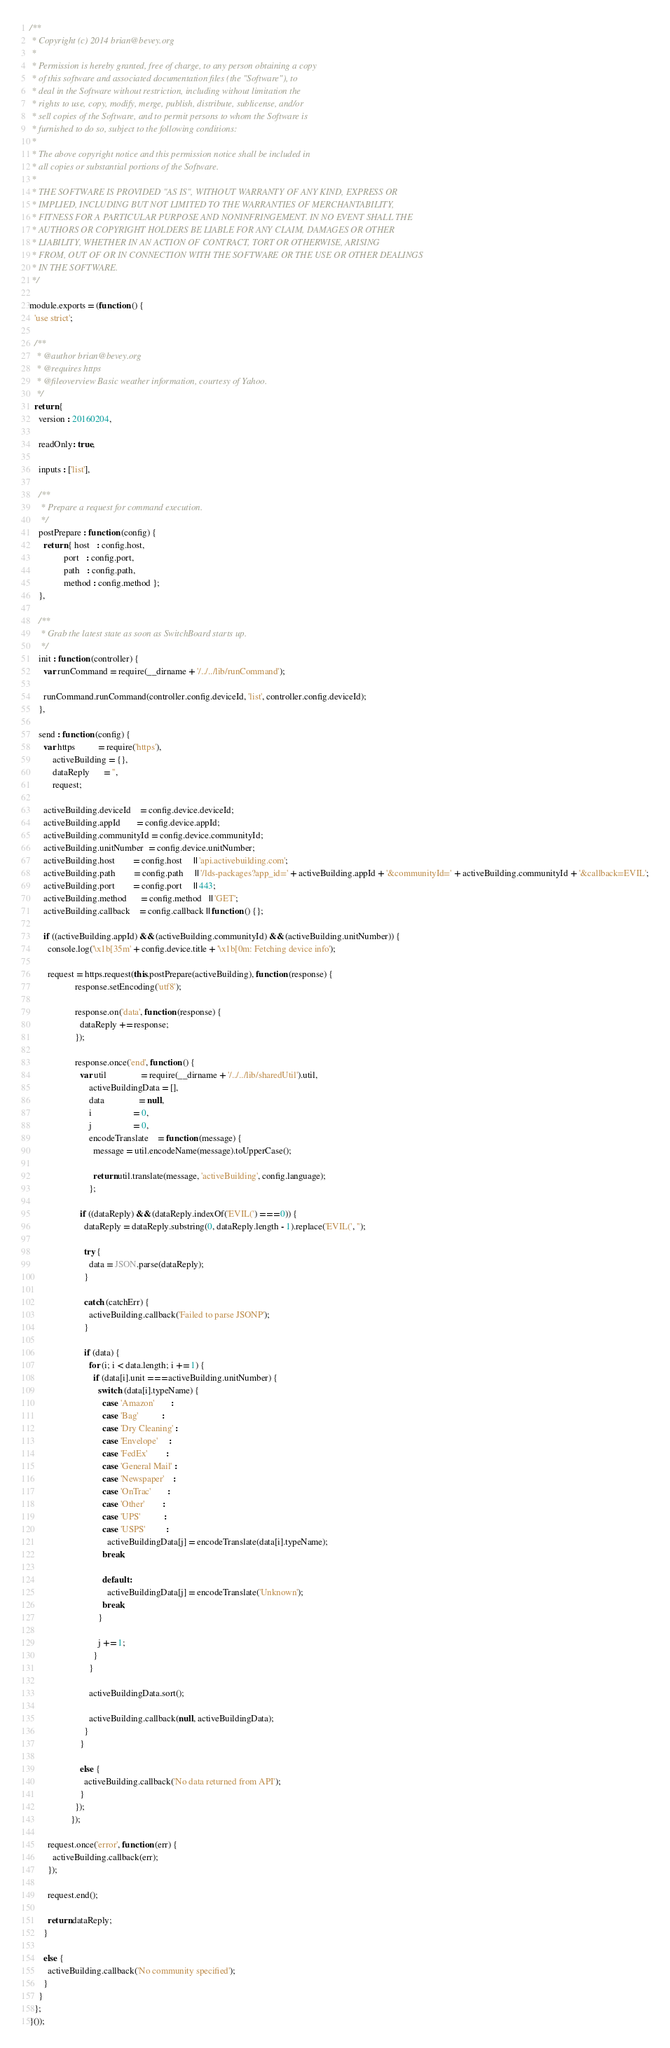Convert code to text. <code><loc_0><loc_0><loc_500><loc_500><_JavaScript_>/**
 * Copyright (c) 2014 brian@bevey.org
 *
 * Permission is hereby granted, free of charge, to any person obtaining a copy
 * of this software and associated documentation files (the "Software"), to
 * deal in the Software without restriction, including without limitation the
 * rights to use, copy, modify, merge, publish, distribute, sublicense, and/or
 * sell copies of the Software, and to permit persons to whom the Software is
 * furnished to do so, subject to the following conditions:
 *
 * The above copyright notice and this permission notice shall be included in
 * all copies or substantial portions of the Software.
 *
 * THE SOFTWARE IS PROVIDED "AS IS", WITHOUT WARRANTY OF ANY KIND, EXPRESS OR
 * IMPLIED, INCLUDING BUT NOT LIMITED TO THE WARRANTIES OF MERCHANTABILITY,
 * FITNESS FOR A PARTICULAR PURPOSE AND NONINFRINGEMENT. IN NO EVENT SHALL THE
 * AUTHORS OR COPYRIGHT HOLDERS BE LIABLE FOR ANY CLAIM, DAMAGES OR OTHER
 * LIABILITY, WHETHER IN AN ACTION OF CONTRACT, TORT OR OTHERWISE, ARISING
 * FROM, OUT OF OR IN CONNECTION WITH THE SOFTWARE OR THE USE OR OTHER DEALINGS
 * IN THE SOFTWARE.
 */

module.exports = (function () {
  'use strict';

  /**
   * @author brian@bevey.org
   * @requires https
   * @fileoverview Basic weather information, courtesy of Yahoo.
   */
  return {
    version : 20160204,

    readOnly: true,

    inputs : ['list'],

    /**
     * Prepare a request for command execution.
     */
    postPrepare : function (config) {
      return { host   : config.host,
               port   : config.port,
               path   : config.path,
               method : config.method };
    },

    /**
     * Grab the latest state as soon as SwitchBoard starts up.
     */
    init : function (controller) {
      var runCommand = require(__dirname + '/../../lib/runCommand');

      runCommand.runCommand(controller.config.deviceId, 'list', controller.config.deviceId);
    },

    send : function (config) {
      var https          = require('https'),
          activeBuilding = {},
          dataReply      = '',
          request;

      activeBuilding.deviceId    = config.device.deviceId;
      activeBuilding.appId       = config.device.appId;
      activeBuilding.communityId = config.device.communityId;
      activeBuilding.unitNumber  = config.device.unitNumber;
      activeBuilding.host        = config.host     || 'api.activebuilding.com';
      activeBuilding.path        = config.path     || '/lds-packages?app_id=' + activeBuilding.appId + '&communityId=' + activeBuilding.communityId + '&callback=EVIL';
      activeBuilding.port        = config.port     || 443;
      activeBuilding.method      = config.method   || 'GET';
      activeBuilding.callback    = config.callback || function () {};

      if ((activeBuilding.appId) && (activeBuilding.communityId) && (activeBuilding.unitNumber)) {
        console.log('\x1b[35m' + config.device.title + '\x1b[0m: Fetching device info');

        request = https.request(this.postPrepare(activeBuilding), function (response) {
                    response.setEncoding('utf8');

                    response.on('data', function (response) {
                      dataReply += response;
                    });

                    response.once('end', function () {
                      var util               = require(__dirname + '/../../lib/sharedUtil').util,
                          activeBuildingData = [],
                          data               = null,
                          i                  = 0,
                          j                  = 0,
                          encodeTranslate    = function (message) {
                            message = util.encodeName(message).toUpperCase();

                            return util.translate(message, 'activeBuilding', config.language);
                          };

                      if ((dataReply) && (dataReply.indexOf('EVIL(') === 0)) {
                        dataReply = dataReply.substring(0, dataReply.length - 1).replace('EVIL(', '');

                        try {
                          data = JSON.parse(dataReply);
                        }

                        catch (catchErr) {
                          activeBuilding.callback('Failed to parse JSONP');
                        }

                        if (data) {
                          for (i; i < data.length; i += 1) {
                            if (data[i].unit === activeBuilding.unitNumber) {
                              switch (data[i].typeName) {
                                case 'Amazon'       :
                                case 'Bag'          :
                                case 'Dry Cleaning' :
                                case 'Envelope'     :
                                case 'FedEx'        :
                                case 'General Mail' :
                                case 'Newspaper'    :
                                case 'OnTrac'       :
                                case 'Other'        :
                                case 'UPS'          :
                                case 'USPS'         :
                                  activeBuildingData[j] = encodeTranslate(data[i].typeName);
                                break;

                                default :
                                  activeBuildingData[j] = encodeTranslate('Unknown');
                                break;
                              }

                              j += 1;
                            }
                          }

                          activeBuildingData.sort();

                          activeBuilding.callback(null, activeBuildingData);
                        }
                      }

                      else {
                        activeBuilding.callback('No data returned from API');
                      }
                    });
                  });

        request.once('error', function (err) {
          activeBuilding.callback(err);
        });

        request.end();

        return dataReply;
      }

      else {
        activeBuilding.callback('No community specified');
      }
    }
  };
}());
</code> 